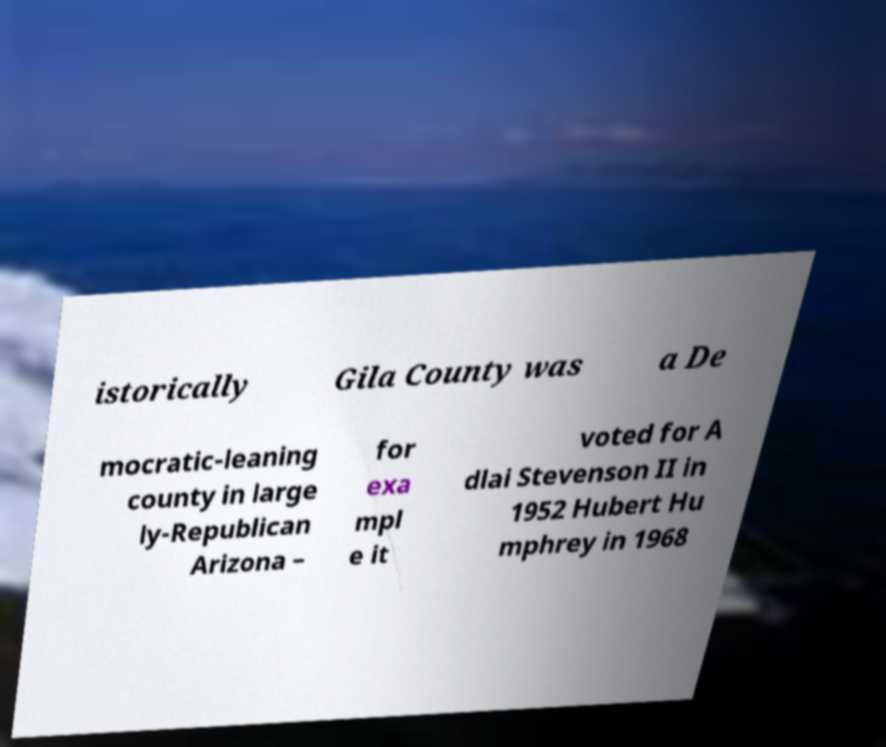For documentation purposes, I need the text within this image transcribed. Could you provide that? istorically Gila County was a De mocratic-leaning county in large ly-Republican Arizona – for exa mpl e it voted for A dlai Stevenson II in 1952 Hubert Hu mphrey in 1968 